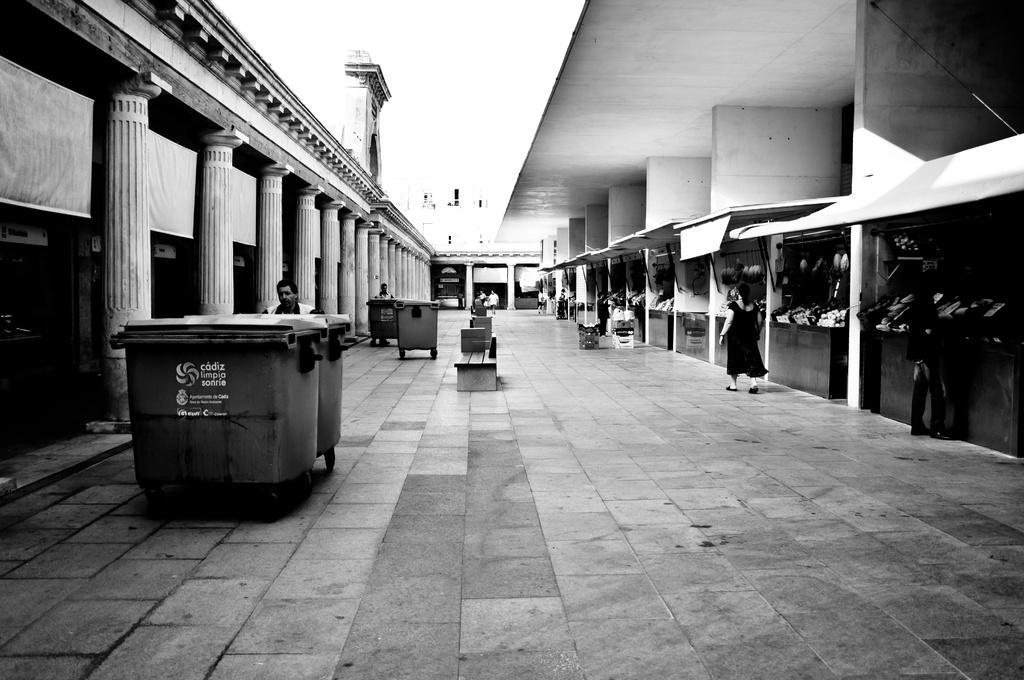Could you give a brief overview of what you see in this image? Here in this picture in the middle we can see some people pushing the garbage boxes and on the right side we can see other people standing and walking and we can also see shops present on the right side and on the left side we can see pillars of the building present and in the middle we can see a bench with somethings pressing on it over there. 